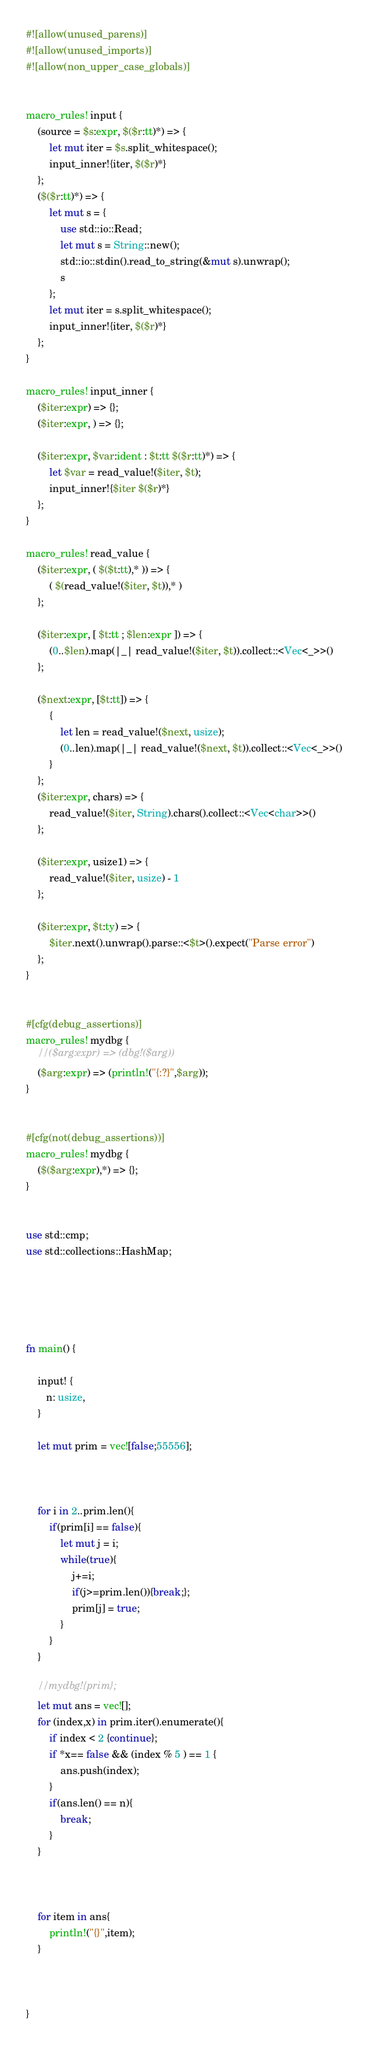Convert code to text. <code><loc_0><loc_0><loc_500><loc_500><_Rust_>#![allow(unused_parens)]
#![allow(unused_imports)]
#![allow(non_upper_case_globals)]


macro_rules! input {
    (source = $s:expr, $($r:tt)*) => {
        let mut iter = $s.split_whitespace();
        input_inner!{iter, $($r)*}
    };
    ($($r:tt)*) => {
        let mut s = {
            use std::io::Read;
            let mut s = String::new();
            std::io::stdin().read_to_string(&mut s).unwrap();
            s
        };
        let mut iter = s.split_whitespace();
        input_inner!{iter, $($r)*}
    };
}

macro_rules! input_inner {
    ($iter:expr) => {};
    ($iter:expr, ) => {};

    ($iter:expr, $var:ident : $t:tt $($r:tt)*) => {
        let $var = read_value!($iter, $t);
        input_inner!{$iter $($r)*}
    };
}

macro_rules! read_value {
    ($iter:expr, ( $($t:tt),* )) => {
        ( $(read_value!($iter, $t)),* )
    };

    ($iter:expr, [ $t:tt ; $len:expr ]) => {
        (0..$len).map(|_| read_value!($iter, $t)).collect::<Vec<_>>()
    };

    ($next:expr, [$t:tt]) => {
        {
            let len = read_value!($next, usize);
            (0..len).map(|_| read_value!($next, $t)).collect::<Vec<_>>()
        }
    };
    ($iter:expr, chars) => {
        read_value!($iter, String).chars().collect::<Vec<char>>()
    };

    ($iter:expr, usize1) => {
        read_value!($iter, usize) - 1
    };

    ($iter:expr, $t:ty) => {
        $iter.next().unwrap().parse::<$t>().expect("Parse error")
    };
}


#[cfg(debug_assertions)]
macro_rules! mydbg {
    //($arg:expr) => (dbg!($arg))
    ($arg:expr) => (println!("{:?}",$arg));
}


#[cfg(not(debug_assertions))]
macro_rules! mydbg {
    ($($arg:expr),*) => {};
}


use std::cmp;
use std::collections::HashMap;





fn main() {

    input! { 
       n: usize,
    }

    let mut prim = vec![false;55556];
    
    

    for i in 2..prim.len(){
        if(prim[i] == false){
            let mut j = i;
            while(true){
                j+=i;
                if(j>=prim.len()){break;};
                prim[j] = true;
            }
        }
    }

    //mydbg!{prim};
    let mut ans = vec![];
    for (index,x) in prim.iter().enumerate(){
        if index < 2 {continue};
        if *x== false && (index % 5 ) == 1 {
            ans.push(index);
        }
        if(ans.len() == n){
            break;
        }
    }    


    
    for item in ans{
        println!("{}",item);
    }
    


}
</code> 